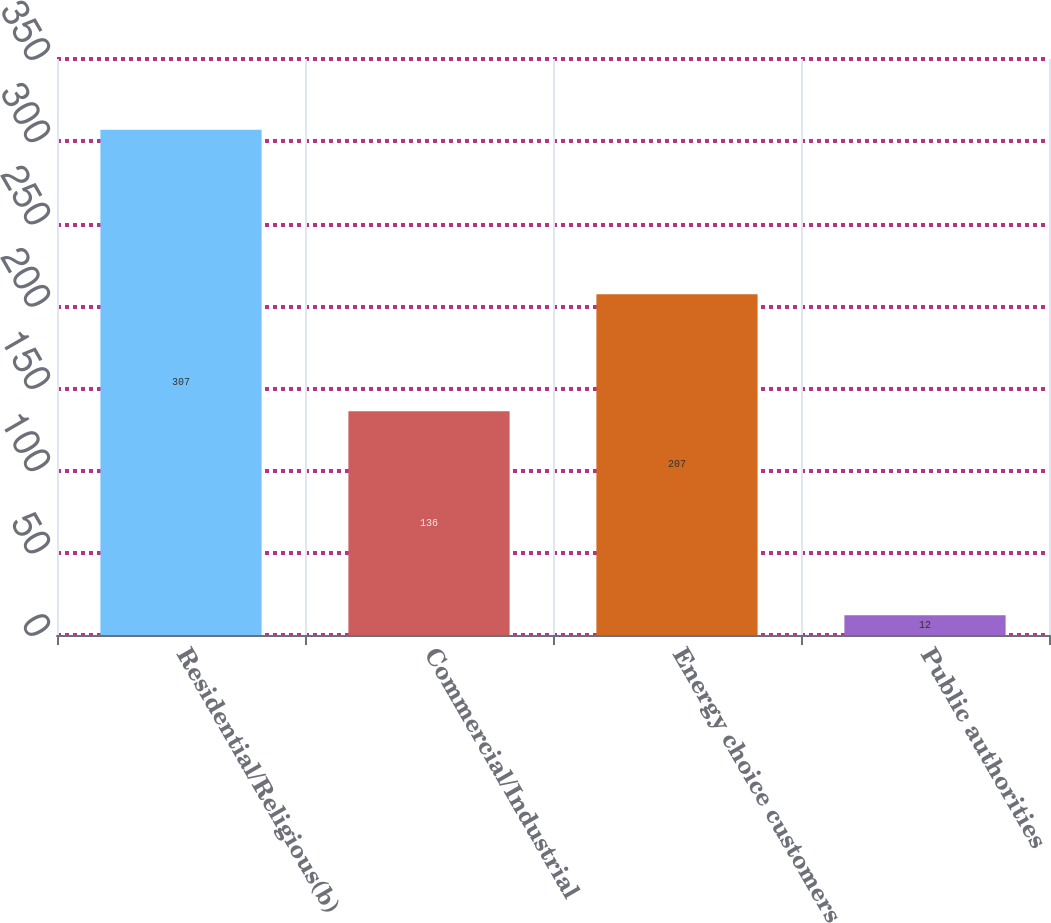Convert chart. <chart><loc_0><loc_0><loc_500><loc_500><bar_chart><fcel>Residential/Religious(b)<fcel>Commercial/Industrial<fcel>Energy choice customers<fcel>Public authorities<nl><fcel>307<fcel>136<fcel>207<fcel>12<nl></chart> 